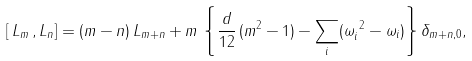Convert formula to latex. <formula><loc_0><loc_0><loc_500><loc_500>& \left [ \, L _ { m } \, , L _ { n } \right ] = ( m - n ) \, L _ { m + n } + m \, \left \{ \frac { d } { 1 2 } \, ( m ^ { 2 } - 1 ) - \sum _ { i } ( \omega _ { i } ^ { \ 2 } - \omega _ { i } ) \right \} \delta _ { m + n , 0 } ,</formula> 